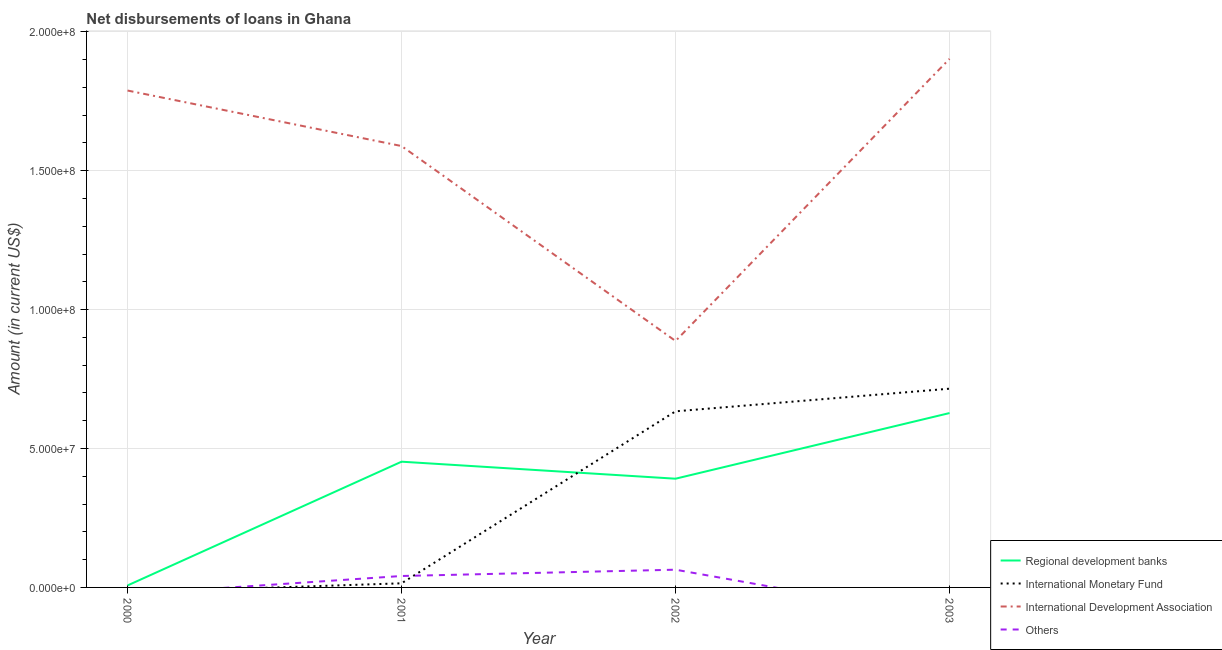How many different coloured lines are there?
Provide a short and direct response. 4. Does the line corresponding to amount of loan disimbursed by regional development banks intersect with the line corresponding to amount of loan disimbursed by international monetary fund?
Make the answer very short. Yes. Is the number of lines equal to the number of legend labels?
Your answer should be very brief. No. What is the amount of loan disimbursed by international development association in 2002?
Offer a terse response. 8.87e+07. Across all years, what is the maximum amount of loan disimbursed by other organisations?
Provide a succinct answer. 6.38e+06. In which year was the amount of loan disimbursed by regional development banks maximum?
Provide a short and direct response. 2003. What is the total amount of loan disimbursed by international development association in the graph?
Offer a very short reply. 6.17e+08. What is the difference between the amount of loan disimbursed by international monetary fund in 2001 and that in 2003?
Give a very brief answer. -7.01e+07. What is the difference between the amount of loan disimbursed by international monetary fund in 2000 and the amount of loan disimbursed by international development association in 2001?
Offer a very short reply. -1.59e+08. What is the average amount of loan disimbursed by regional development banks per year?
Provide a short and direct response. 3.70e+07. In the year 2001, what is the difference between the amount of loan disimbursed by international monetary fund and amount of loan disimbursed by regional development banks?
Provide a short and direct response. -4.38e+07. What is the ratio of the amount of loan disimbursed by other organisations in 2001 to that in 2002?
Your answer should be compact. 0.64. Is the amount of loan disimbursed by regional development banks in 2000 less than that in 2001?
Offer a terse response. Yes. Is the difference between the amount of loan disimbursed by regional development banks in 2001 and 2002 greater than the difference between the amount of loan disimbursed by international monetary fund in 2001 and 2002?
Keep it short and to the point. Yes. What is the difference between the highest and the second highest amount of loan disimbursed by international monetary fund?
Provide a short and direct response. 8.15e+06. What is the difference between the highest and the lowest amount of loan disimbursed by international development association?
Your answer should be compact. 1.02e+08. In how many years, is the amount of loan disimbursed by international development association greater than the average amount of loan disimbursed by international development association taken over all years?
Ensure brevity in your answer.  3. Is the amount of loan disimbursed by international development association strictly greater than the amount of loan disimbursed by international monetary fund over the years?
Offer a very short reply. Yes. How many lines are there?
Give a very brief answer. 4. What is the difference between two consecutive major ticks on the Y-axis?
Provide a short and direct response. 5.00e+07. Are the values on the major ticks of Y-axis written in scientific E-notation?
Your answer should be very brief. Yes. Does the graph contain any zero values?
Provide a succinct answer. Yes. Where does the legend appear in the graph?
Your answer should be very brief. Bottom right. What is the title of the graph?
Offer a very short reply. Net disbursements of loans in Ghana. What is the label or title of the Y-axis?
Keep it short and to the point. Amount (in current US$). What is the Amount (in current US$) of Regional development banks in 2000?
Your answer should be compact. 7.06e+05. What is the Amount (in current US$) in International Monetary Fund in 2000?
Make the answer very short. 0. What is the Amount (in current US$) in International Development Association in 2000?
Make the answer very short. 1.79e+08. What is the Amount (in current US$) of Regional development banks in 2001?
Your answer should be very brief. 4.53e+07. What is the Amount (in current US$) in International Monetary Fund in 2001?
Give a very brief answer. 1.48e+06. What is the Amount (in current US$) of International Development Association in 2001?
Provide a short and direct response. 1.59e+08. What is the Amount (in current US$) of Others in 2001?
Your response must be concise. 4.12e+06. What is the Amount (in current US$) of Regional development banks in 2002?
Offer a very short reply. 3.91e+07. What is the Amount (in current US$) in International Monetary Fund in 2002?
Provide a short and direct response. 6.34e+07. What is the Amount (in current US$) of International Development Association in 2002?
Keep it short and to the point. 8.87e+07. What is the Amount (in current US$) of Others in 2002?
Your answer should be very brief. 6.38e+06. What is the Amount (in current US$) of Regional development banks in 2003?
Provide a short and direct response. 6.28e+07. What is the Amount (in current US$) in International Monetary Fund in 2003?
Your answer should be very brief. 7.15e+07. What is the Amount (in current US$) of International Development Association in 2003?
Ensure brevity in your answer.  1.90e+08. Across all years, what is the maximum Amount (in current US$) in Regional development banks?
Offer a terse response. 6.28e+07. Across all years, what is the maximum Amount (in current US$) of International Monetary Fund?
Ensure brevity in your answer.  7.15e+07. Across all years, what is the maximum Amount (in current US$) in International Development Association?
Offer a very short reply. 1.90e+08. Across all years, what is the maximum Amount (in current US$) of Others?
Keep it short and to the point. 6.38e+06. Across all years, what is the minimum Amount (in current US$) of Regional development banks?
Offer a terse response. 7.06e+05. Across all years, what is the minimum Amount (in current US$) of International Monetary Fund?
Provide a short and direct response. 0. Across all years, what is the minimum Amount (in current US$) of International Development Association?
Offer a terse response. 8.87e+07. What is the total Amount (in current US$) of Regional development banks in the graph?
Ensure brevity in your answer.  1.48e+08. What is the total Amount (in current US$) of International Monetary Fund in the graph?
Offer a very short reply. 1.36e+08. What is the total Amount (in current US$) of International Development Association in the graph?
Offer a terse response. 6.17e+08. What is the total Amount (in current US$) in Others in the graph?
Provide a succinct answer. 1.05e+07. What is the difference between the Amount (in current US$) in Regional development banks in 2000 and that in 2001?
Your response must be concise. -4.46e+07. What is the difference between the Amount (in current US$) in International Development Association in 2000 and that in 2001?
Ensure brevity in your answer.  2.00e+07. What is the difference between the Amount (in current US$) of Regional development banks in 2000 and that in 2002?
Provide a short and direct response. -3.84e+07. What is the difference between the Amount (in current US$) of International Development Association in 2000 and that in 2002?
Keep it short and to the point. 9.02e+07. What is the difference between the Amount (in current US$) in Regional development banks in 2000 and that in 2003?
Your response must be concise. -6.21e+07. What is the difference between the Amount (in current US$) in International Development Association in 2000 and that in 2003?
Keep it short and to the point. -1.14e+07. What is the difference between the Amount (in current US$) in Regional development banks in 2001 and that in 2002?
Provide a succinct answer. 6.12e+06. What is the difference between the Amount (in current US$) of International Monetary Fund in 2001 and that in 2002?
Your answer should be very brief. -6.19e+07. What is the difference between the Amount (in current US$) of International Development Association in 2001 and that in 2002?
Ensure brevity in your answer.  7.02e+07. What is the difference between the Amount (in current US$) in Others in 2001 and that in 2002?
Your response must be concise. -2.27e+06. What is the difference between the Amount (in current US$) of Regional development banks in 2001 and that in 2003?
Offer a very short reply. -1.75e+07. What is the difference between the Amount (in current US$) of International Monetary Fund in 2001 and that in 2003?
Your response must be concise. -7.01e+07. What is the difference between the Amount (in current US$) of International Development Association in 2001 and that in 2003?
Give a very brief answer. -3.14e+07. What is the difference between the Amount (in current US$) in Regional development banks in 2002 and that in 2003?
Offer a terse response. -2.36e+07. What is the difference between the Amount (in current US$) in International Monetary Fund in 2002 and that in 2003?
Your answer should be compact. -8.15e+06. What is the difference between the Amount (in current US$) of International Development Association in 2002 and that in 2003?
Offer a very short reply. -1.02e+08. What is the difference between the Amount (in current US$) in Regional development banks in 2000 and the Amount (in current US$) in International Monetary Fund in 2001?
Ensure brevity in your answer.  -7.77e+05. What is the difference between the Amount (in current US$) of Regional development banks in 2000 and the Amount (in current US$) of International Development Association in 2001?
Ensure brevity in your answer.  -1.58e+08. What is the difference between the Amount (in current US$) of Regional development banks in 2000 and the Amount (in current US$) of Others in 2001?
Your response must be concise. -3.41e+06. What is the difference between the Amount (in current US$) of International Development Association in 2000 and the Amount (in current US$) of Others in 2001?
Provide a short and direct response. 1.75e+08. What is the difference between the Amount (in current US$) of Regional development banks in 2000 and the Amount (in current US$) of International Monetary Fund in 2002?
Give a very brief answer. -6.27e+07. What is the difference between the Amount (in current US$) of Regional development banks in 2000 and the Amount (in current US$) of International Development Association in 2002?
Provide a succinct answer. -8.80e+07. What is the difference between the Amount (in current US$) in Regional development banks in 2000 and the Amount (in current US$) in Others in 2002?
Keep it short and to the point. -5.68e+06. What is the difference between the Amount (in current US$) in International Development Association in 2000 and the Amount (in current US$) in Others in 2002?
Give a very brief answer. 1.73e+08. What is the difference between the Amount (in current US$) in Regional development banks in 2000 and the Amount (in current US$) in International Monetary Fund in 2003?
Keep it short and to the point. -7.08e+07. What is the difference between the Amount (in current US$) in Regional development banks in 2000 and the Amount (in current US$) in International Development Association in 2003?
Keep it short and to the point. -1.90e+08. What is the difference between the Amount (in current US$) in Regional development banks in 2001 and the Amount (in current US$) in International Monetary Fund in 2002?
Provide a succinct answer. -1.81e+07. What is the difference between the Amount (in current US$) in Regional development banks in 2001 and the Amount (in current US$) in International Development Association in 2002?
Your answer should be very brief. -4.35e+07. What is the difference between the Amount (in current US$) in Regional development banks in 2001 and the Amount (in current US$) in Others in 2002?
Your answer should be very brief. 3.89e+07. What is the difference between the Amount (in current US$) of International Monetary Fund in 2001 and the Amount (in current US$) of International Development Association in 2002?
Provide a short and direct response. -8.72e+07. What is the difference between the Amount (in current US$) of International Monetary Fund in 2001 and the Amount (in current US$) of Others in 2002?
Offer a very short reply. -4.90e+06. What is the difference between the Amount (in current US$) of International Development Association in 2001 and the Amount (in current US$) of Others in 2002?
Your response must be concise. 1.53e+08. What is the difference between the Amount (in current US$) in Regional development banks in 2001 and the Amount (in current US$) in International Monetary Fund in 2003?
Offer a terse response. -2.63e+07. What is the difference between the Amount (in current US$) in Regional development banks in 2001 and the Amount (in current US$) in International Development Association in 2003?
Provide a succinct answer. -1.45e+08. What is the difference between the Amount (in current US$) of International Monetary Fund in 2001 and the Amount (in current US$) of International Development Association in 2003?
Provide a short and direct response. -1.89e+08. What is the difference between the Amount (in current US$) in Regional development banks in 2002 and the Amount (in current US$) in International Monetary Fund in 2003?
Provide a short and direct response. -3.24e+07. What is the difference between the Amount (in current US$) in Regional development banks in 2002 and the Amount (in current US$) in International Development Association in 2003?
Offer a terse response. -1.51e+08. What is the difference between the Amount (in current US$) in International Monetary Fund in 2002 and the Amount (in current US$) in International Development Association in 2003?
Provide a short and direct response. -1.27e+08. What is the average Amount (in current US$) in Regional development banks per year?
Offer a very short reply. 3.70e+07. What is the average Amount (in current US$) of International Monetary Fund per year?
Offer a very short reply. 3.41e+07. What is the average Amount (in current US$) of International Development Association per year?
Make the answer very short. 1.54e+08. What is the average Amount (in current US$) of Others per year?
Your response must be concise. 2.62e+06. In the year 2000, what is the difference between the Amount (in current US$) of Regional development banks and Amount (in current US$) of International Development Association?
Offer a terse response. -1.78e+08. In the year 2001, what is the difference between the Amount (in current US$) of Regional development banks and Amount (in current US$) of International Monetary Fund?
Your answer should be compact. 4.38e+07. In the year 2001, what is the difference between the Amount (in current US$) in Regional development banks and Amount (in current US$) in International Development Association?
Keep it short and to the point. -1.14e+08. In the year 2001, what is the difference between the Amount (in current US$) of Regional development banks and Amount (in current US$) of Others?
Provide a short and direct response. 4.12e+07. In the year 2001, what is the difference between the Amount (in current US$) of International Monetary Fund and Amount (in current US$) of International Development Association?
Offer a very short reply. -1.57e+08. In the year 2001, what is the difference between the Amount (in current US$) of International Monetary Fund and Amount (in current US$) of Others?
Offer a very short reply. -2.63e+06. In the year 2001, what is the difference between the Amount (in current US$) in International Development Association and Amount (in current US$) in Others?
Make the answer very short. 1.55e+08. In the year 2002, what is the difference between the Amount (in current US$) of Regional development banks and Amount (in current US$) of International Monetary Fund?
Provide a succinct answer. -2.43e+07. In the year 2002, what is the difference between the Amount (in current US$) in Regional development banks and Amount (in current US$) in International Development Association?
Your response must be concise. -4.96e+07. In the year 2002, what is the difference between the Amount (in current US$) of Regional development banks and Amount (in current US$) of Others?
Offer a very short reply. 3.28e+07. In the year 2002, what is the difference between the Amount (in current US$) in International Monetary Fund and Amount (in current US$) in International Development Association?
Make the answer very short. -2.53e+07. In the year 2002, what is the difference between the Amount (in current US$) of International Monetary Fund and Amount (in current US$) of Others?
Provide a short and direct response. 5.70e+07. In the year 2002, what is the difference between the Amount (in current US$) in International Development Association and Amount (in current US$) in Others?
Provide a succinct answer. 8.23e+07. In the year 2003, what is the difference between the Amount (in current US$) in Regional development banks and Amount (in current US$) in International Monetary Fund?
Keep it short and to the point. -8.77e+06. In the year 2003, what is the difference between the Amount (in current US$) of Regional development banks and Amount (in current US$) of International Development Association?
Your answer should be very brief. -1.28e+08. In the year 2003, what is the difference between the Amount (in current US$) of International Monetary Fund and Amount (in current US$) of International Development Association?
Ensure brevity in your answer.  -1.19e+08. What is the ratio of the Amount (in current US$) in Regional development banks in 2000 to that in 2001?
Your response must be concise. 0.02. What is the ratio of the Amount (in current US$) in International Development Association in 2000 to that in 2001?
Your answer should be compact. 1.13. What is the ratio of the Amount (in current US$) of Regional development banks in 2000 to that in 2002?
Provide a short and direct response. 0.02. What is the ratio of the Amount (in current US$) of International Development Association in 2000 to that in 2002?
Provide a short and direct response. 2.02. What is the ratio of the Amount (in current US$) in Regional development banks in 2000 to that in 2003?
Your response must be concise. 0.01. What is the ratio of the Amount (in current US$) in Regional development banks in 2001 to that in 2002?
Provide a short and direct response. 1.16. What is the ratio of the Amount (in current US$) in International Monetary Fund in 2001 to that in 2002?
Provide a succinct answer. 0.02. What is the ratio of the Amount (in current US$) in International Development Association in 2001 to that in 2002?
Give a very brief answer. 1.79. What is the ratio of the Amount (in current US$) of Others in 2001 to that in 2002?
Ensure brevity in your answer.  0.64. What is the ratio of the Amount (in current US$) of Regional development banks in 2001 to that in 2003?
Your answer should be very brief. 0.72. What is the ratio of the Amount (in current US$) of International Monetary Fund in 2001 to that in 2003?
Offer a terse response. 0.02. What is the ratio of the Amount (in current US$) of International Development Association in 2001 to that in 2003?
Provide a short and direct response. 0.83. What is the ratio of the Amount (in current US$) in Regional development banks in 2002 to that in 2003?
Offer a very short reply. 0.62. What is the ratio of the Amount (in current US$) in International Monetary Fund in 2002 to that in 2003?
Give a very brief answer. 0.89. What is the ratio of the Amount (in current US$) in International Development Association in 2002 to that in 2003?
Your answer should be very brief. 0.47. What is the difference between the highest and the second highest Amount (in current US$) of Regional development banks?
Provide a succinct answer. 1.75e+07. What is the difference between the highest and the second highest Amount (in current US$) of International Monetary Fund?
Provide a succinct answer. 8.15e+06. What is the difference between the highest and the second highest Amount (in current US$) in International Development Association?
Your answer should be very brief. 1.14e+07. What is the difference between the highest and the lowest Amount (in current US$) of Regional development banks?
Your answer should be compact. 6.21e+07. What is the difference between the highest and the lowest Amount (in current US$) in International Monetary Fund?
Make the answer very short. 7.15e+07. What is the difference between the highest and the lowest Amount (in current US$) in International Development Association?
Keep it short and to the point. 1.02e+08. What is the difference between the highest and the lowest Amount (in current US$) of Others?
Your response must be concise. 6.38e+06. 